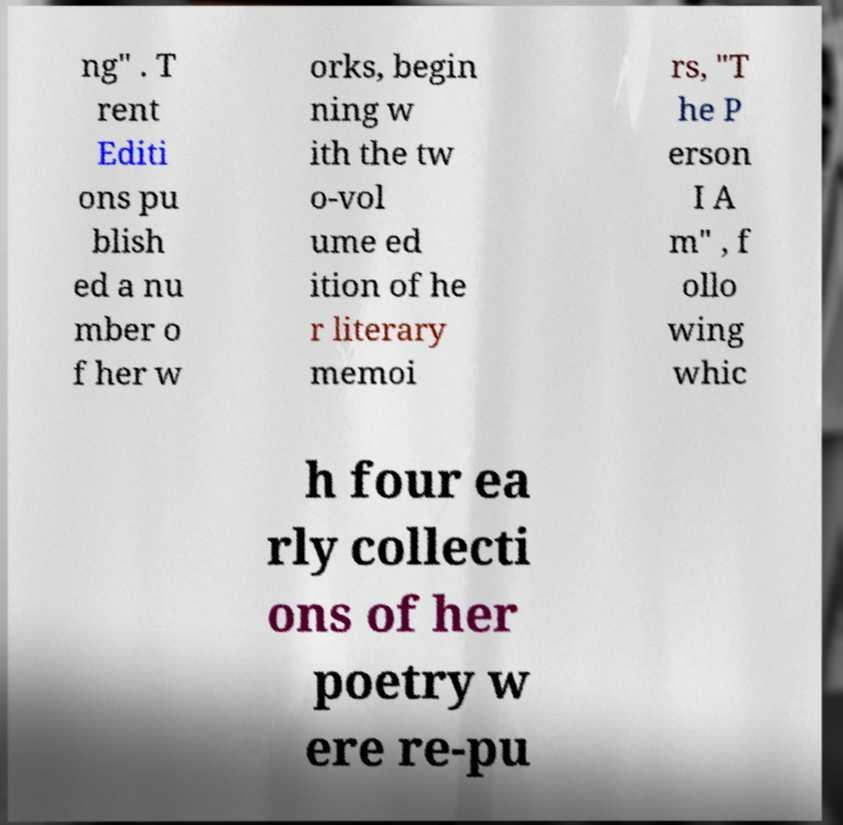Could you assist in decoding the text presented in this image and type it out clearly? ng" . T rent Editi ons pu blish ed a nu mber o f her w orks, begin ning w ith the tw o-vol ume ed ition of he r literary memoi rs, "T he P erson I A m" , f ollo wing whic h four ea rly collecti ons of her poetry w ere re-pu 